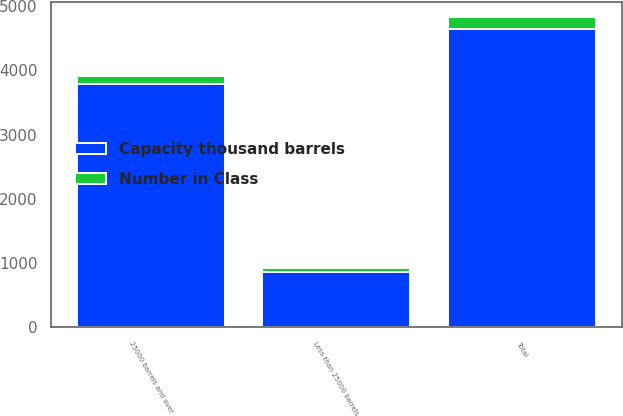<chart> <loc_0><loc_0><loc_500><loc_500><stacked_bar_chart><ecel><fcel>Less than 25000 barrels<fcel>25000 barrels and over<fcel>Total<nl><fcel>Number in Class<fcel>61<fcel>130<fcel>191<nl><fcel>Capacity thousand barrels<fcel>858<fcel>3784<fcel>4642<nl></chart> 